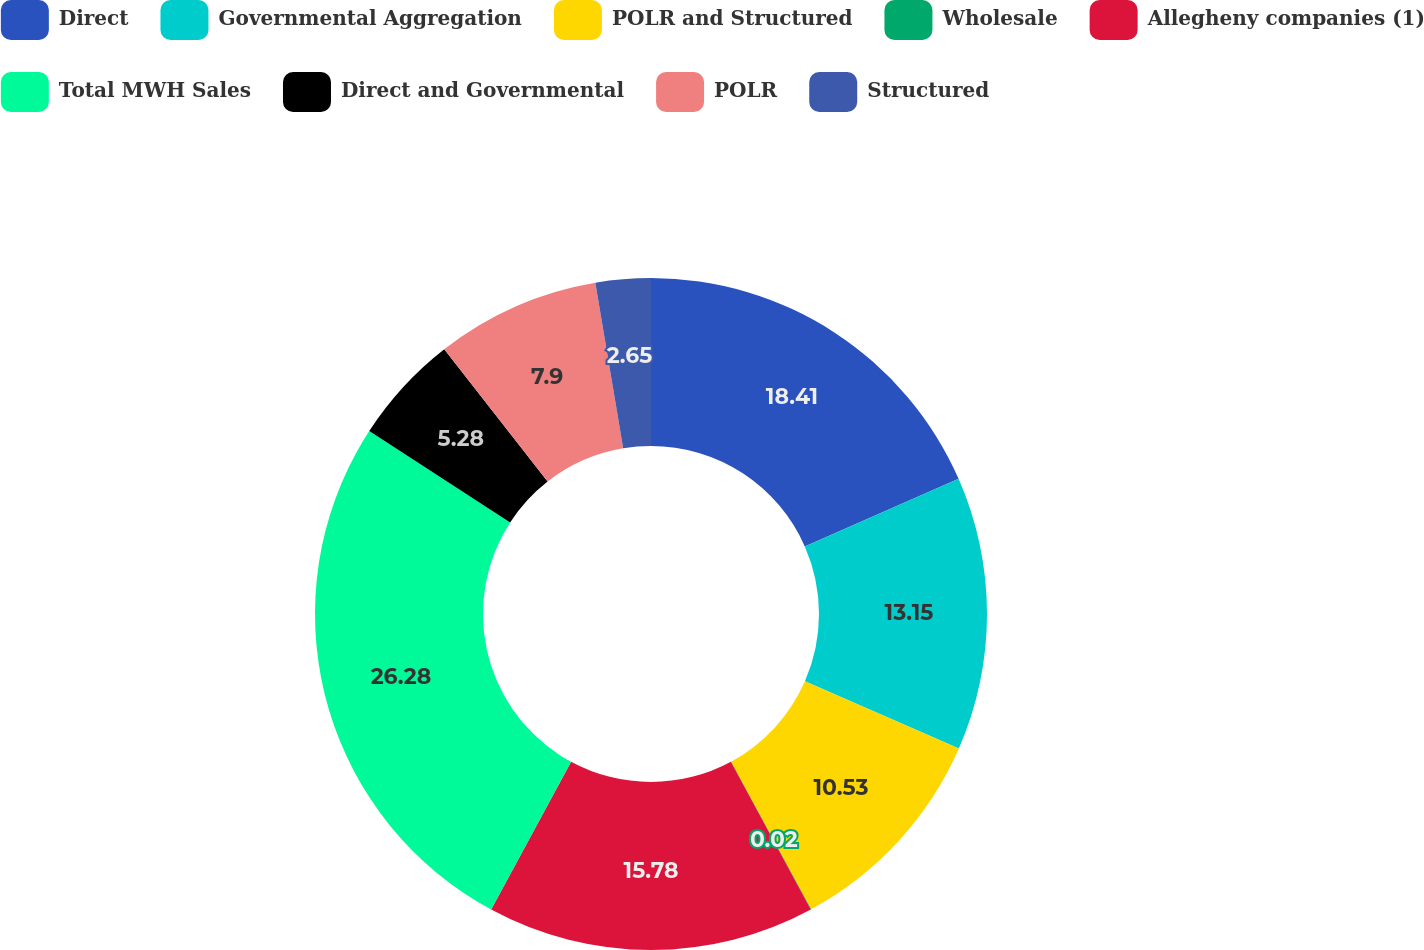Convert chart. <chart><loc_0><loc_0><loc_500><loc_500><pie_chart><fcel>Direct<fcel>Governmental Aggregation<fcel>POLR and Structured<fcel>Wholesale<fcel>Allegheny companies (1)<fcel>Total MWH Sales<fcel>Direct and Governmental<fcel>POLR<fcel>Structured<nl><fcel>18.41%<fcel>13.15%<fcel>10.53%<fcel>0.02%<fcel>15.78%<fcel>26.28%<fcel>5.28%<fcel>7.9%<fcel>2.65%<nl></chart> 